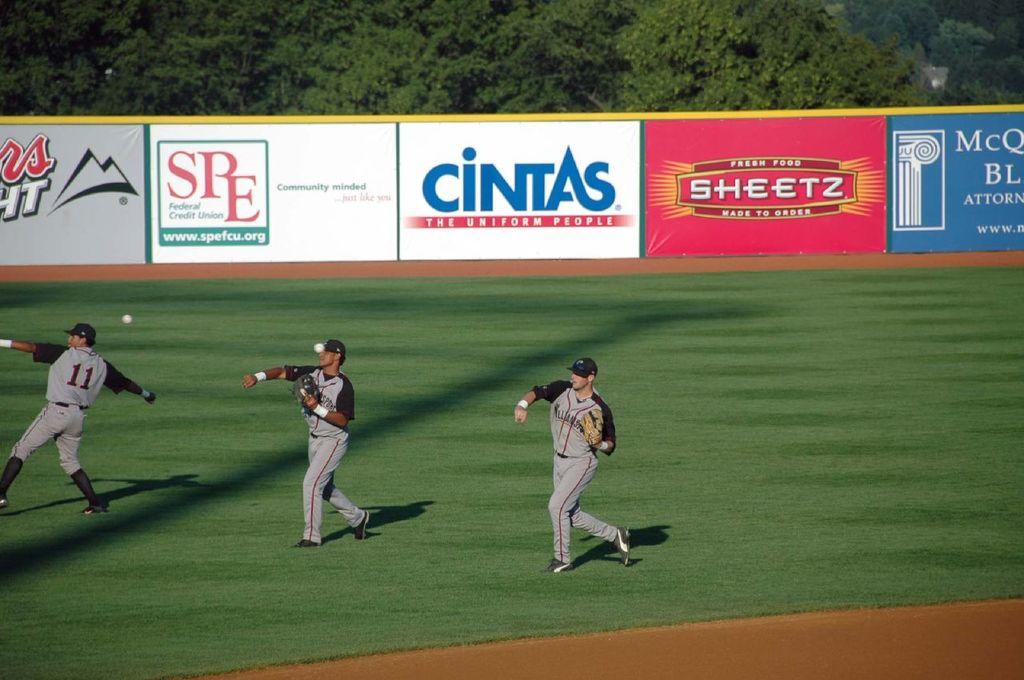What bill board beer company is one the posters on the fence?
Provide a succinct answer. Coors light. 